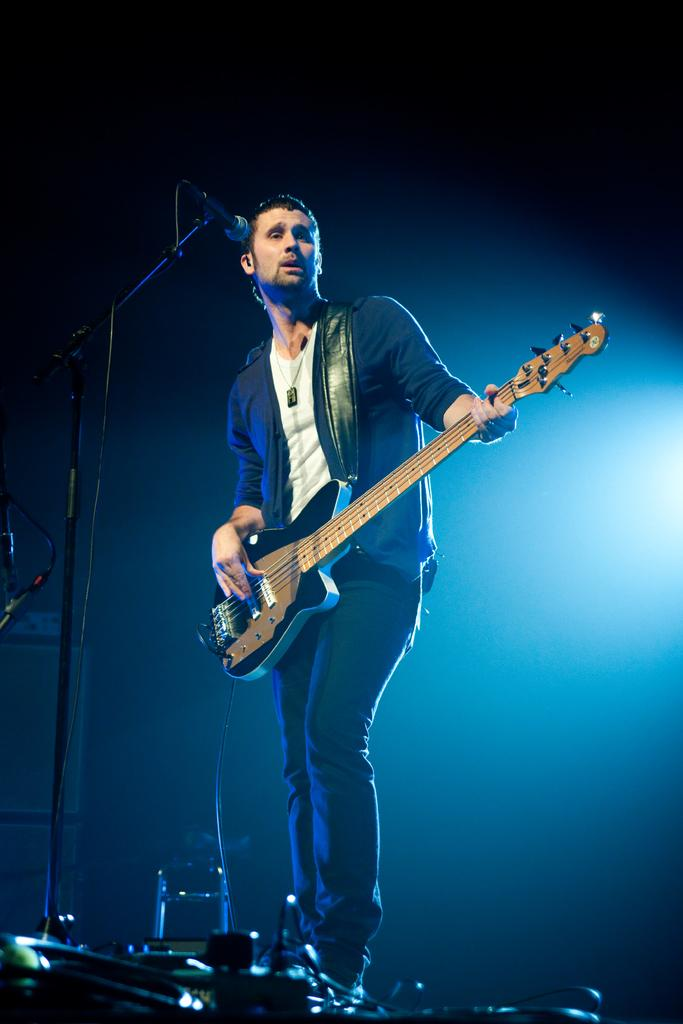What is the main subject of the picture? The main subject of the picture is a man. What is the man doing in the image? The man is standing and appears to be singing. What instrument is the man wearing in the image? The man is wearing a guitar around his shoulders. What object is in front of the man? There is a microphone in front of the man. How would you describe the lighting in the image? The background of the image is covered with bright light. What type of riddle is the man trying to solve in the image? There is no riddle present in the image; the man is singing with a guitar and microphone. Can you tell me how many police officers are visible in the image? There are no police officers present in the image. 